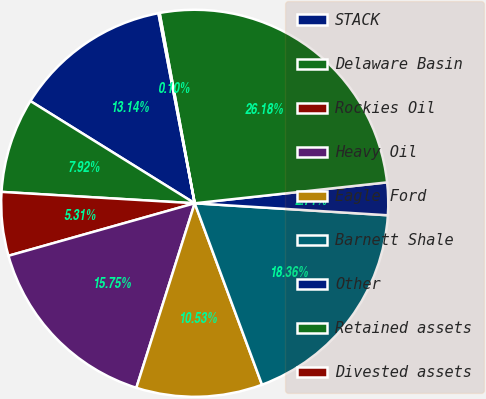Convert chart to OTSL. <chart><loc_0><loc_0><loc_500><loc_500><pie_chart><fcel>STACK<fcel>Delaware Basin<fcel>Rockies Oil<fcel>Heavy Oil<fcel>Eagle Ford<fcel>Barnett Shale<fcel>Other<fcel>Retained assets<fcel>Divested assets<nl><fcel>13.14%<fcel>7.92%<fcel>5.31%<fcel>15.75%<fcel>10.53%<fcel>18.36%<fcel>2.71%<fcel>26.18%<fcel>0.1%<nl></chart> 